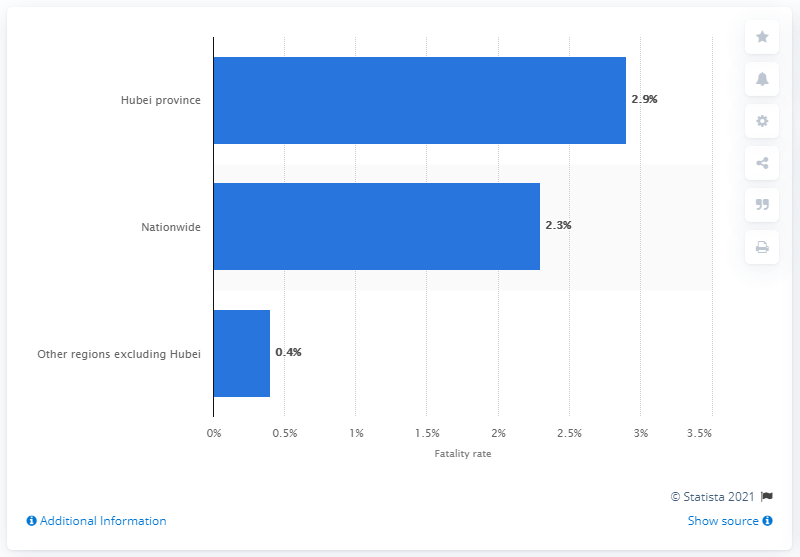Outline some significant characteristics in this image. As of February 11, 2020, the fatality rate of COVID-19 in China was 2.3%. Wuhan city is located in the Hubei province. 